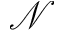<formula> <loc_0><loc_0><loc_500><loc_500>\ m a t h s c r { N }</formula> 